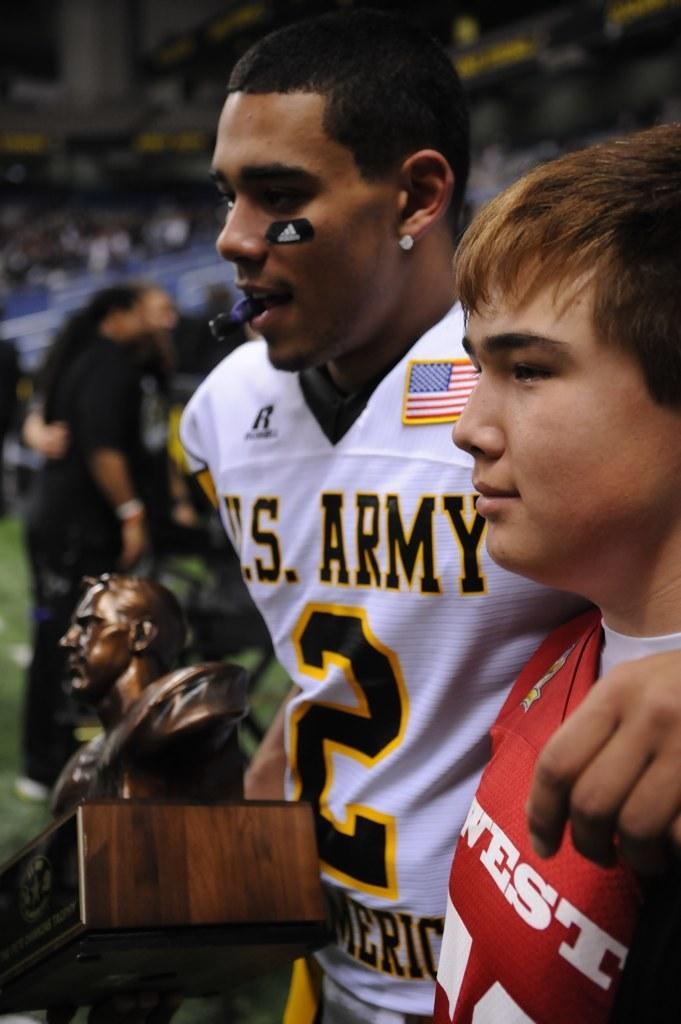Describe this image in one or two sentences. In the image there are two boys and the second boy is holding some object in his hand and the background of the boys is blur. 